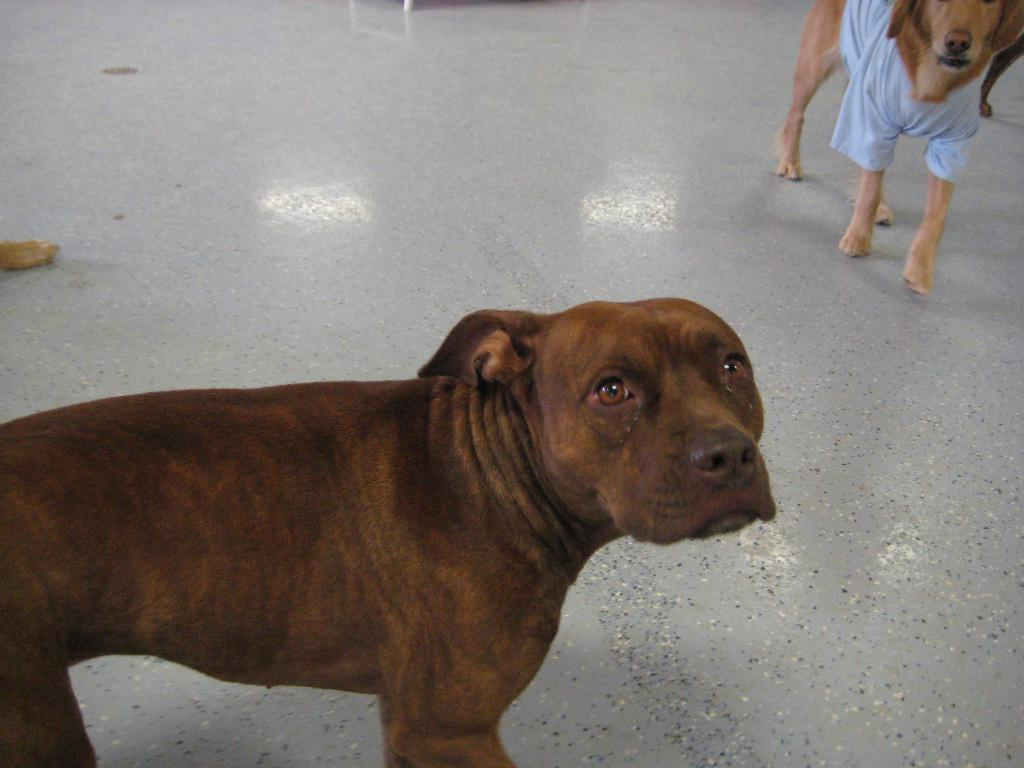What type of animals are present in the image? There are dogs in the image. Where are the dogs located? The dogs are on the floor. Can you describe any unique features of the dogs in the image? One of the dogs is wearing a shirt. What type of cushion is the dog sitting on in the image? There is no cushion present in the image; the dogs are on the floor. How many beads are visible on the dog's collar in the image? There are no beads visible on the dog's collar in the image, as the dog is not wearing a collar. 